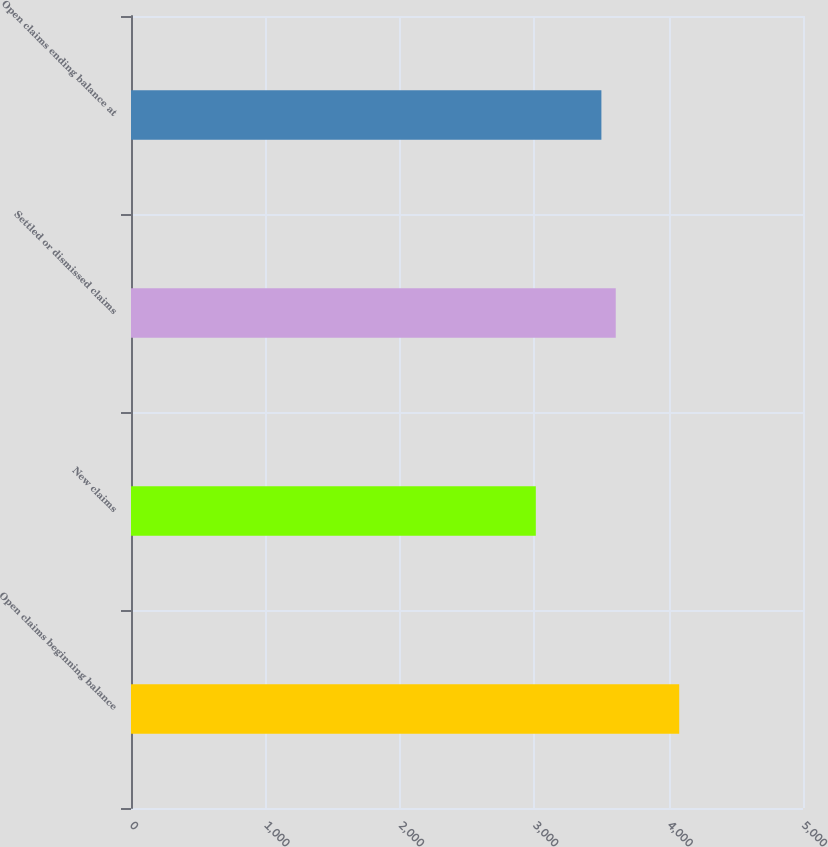Convert chart. <chart><loc_0><loc_0><loc_500><loc_500><bar_chart><fcel>Open claims beginning balance<fcel>New claims<fcel>Settled or dismissed claims<fcel>Open claims ending balance at<nl><fcel>4079<fcel>3012<fcel>3606.7<fcel>3500<nl></chart> 